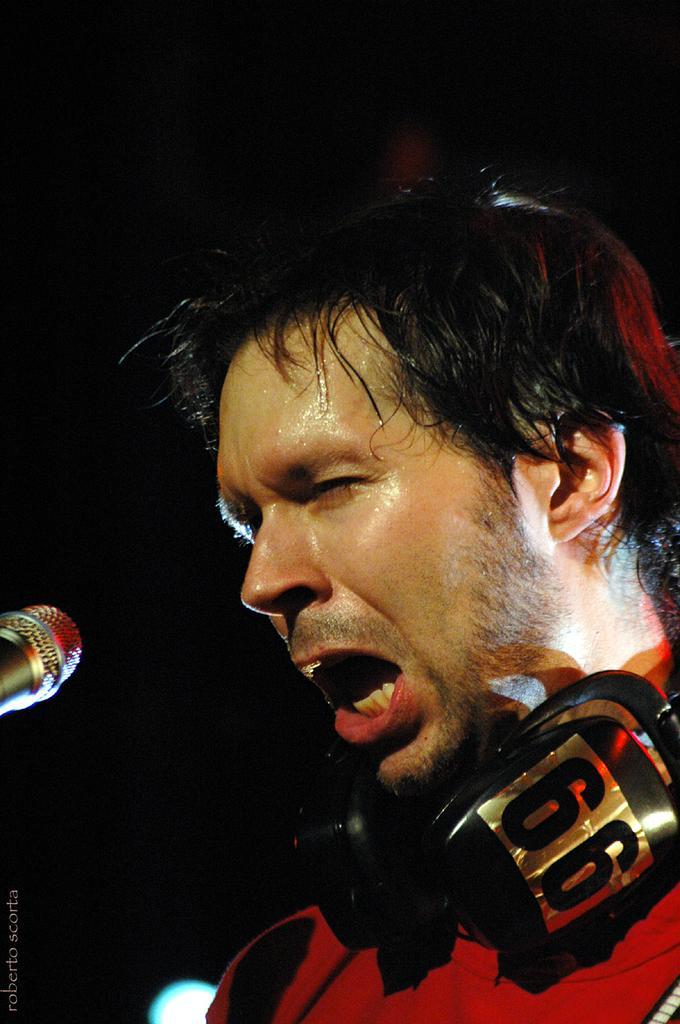Could you give a brief overview of what you see in this image? On the right side we can see a man and there is a headset on his neck and on the right side we can see a mic. In the background the image is dark. 